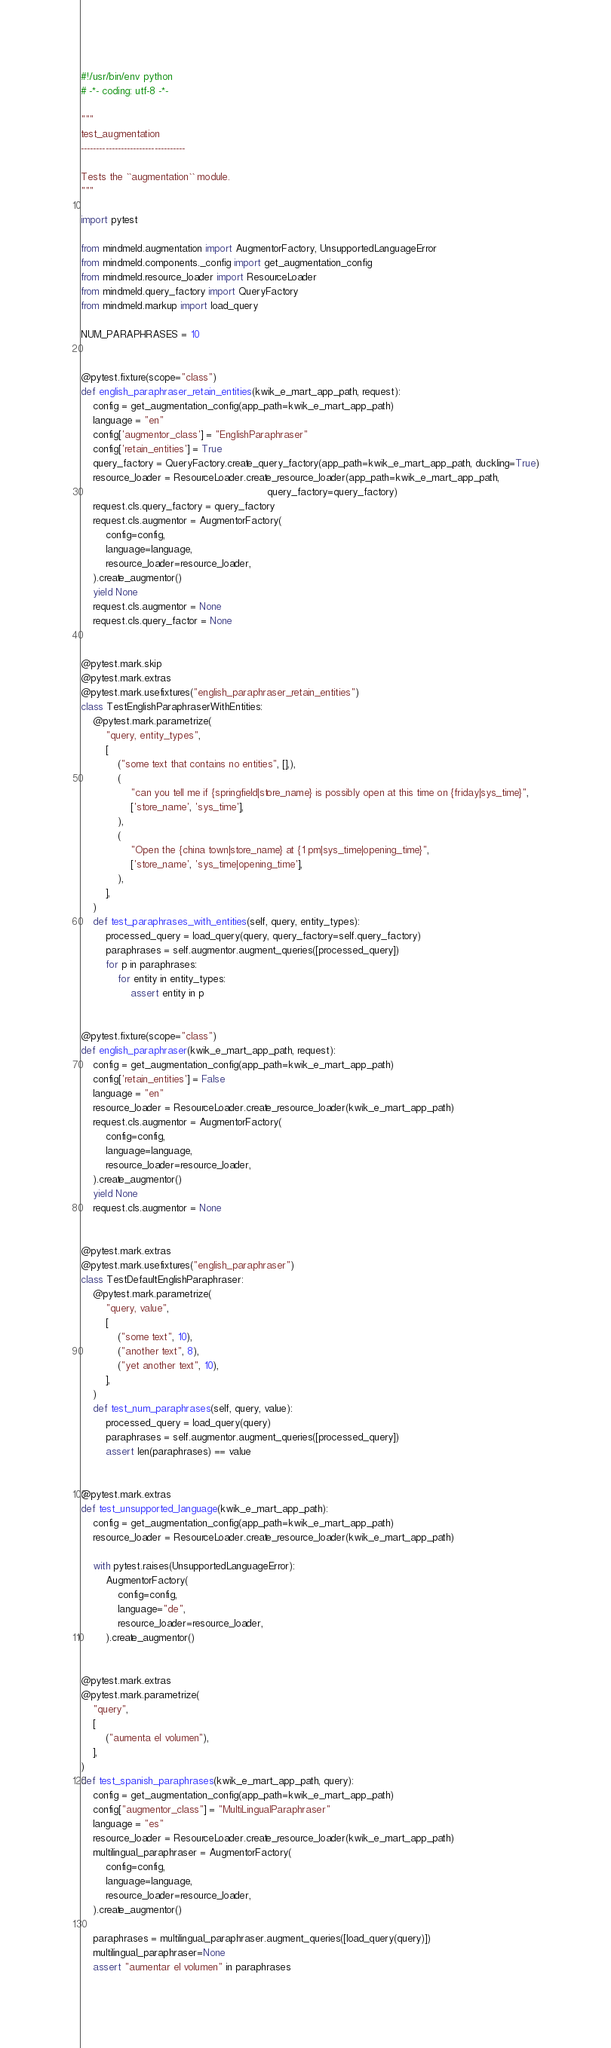<code> <loc_0><loc_0><loc_500><loc_500><_Python_>#!/usr/bin/env python
# -*- coding: utf-8 -*-

"""
test_augmentation
----------------------------------

Tests the ``augmentation`` module.
"""

import pytest

from mindmeld.augmentation import AugmentorFactory, UnsupportedLanguageError
from mindmeld.components._config import get_augmentation_config
from mindmeld.resource_loader import ResourceLoader
from mindmeld.query_factory import QueryFactory
from mindmeld.markup import load_query

NUM_PARAPHRASES = 10


@pytest.fixture(scope="class")
def english_paraphraser_retain_entities(kwik_e_mart_app_path, request):
    config = get_augmentation_config(app_path=kwik_e_mart_app_path)
    language = "en"
    config['augmentor_class'] = "EnglishParaphraser"
    config['retain_entities'] = True
    query_factory = QueryFactory.create_query_factory(app_path=kwik_e_mart_app_path, duckling=True)
    resource_loader = ResourceLoader.create_resource_loader(app_path=kwik_e_mart_app_path,
                                                            query_factory=query_factory)
    request.cls.query_factory = query_factory
    request.cls.augmentor = AugmentorFactory(
        config=config,
        language=language,
        resource_loader=resource_loader,
    ).create_augmentor()
    yield None
    request.cls.augmentor = None
    request.cls.query_factor = None


@pytest.mark.skip
@pytest.mark.extras
@pytest.mark.usefixtures("english_paraphraser_retain_entities")
class TestEnglishParaphraserWithEntities:
    @pytest.mark.parametrize(
        "query, entity_types",
        [
            ("some text that contains no entities", [],),
            (
                "can you tell me if {springfield|store_name} is possibly open at this time on {friday|sys_time}",
                ['store_name', 'sys_time'],
            ),
            (
                "Open the {china town|store_name} at {1 pm|sys_time|opening_time}",
                ['store_name', 'sys_time|opening_time'],
            ),
        ],
    )
    def test_paraphrases_with_entities(self, query, entity_types):
        processed_query = load_query(query, query_factory=self.query_factory)
        paraphrases = self.augmentor.augment_queries([processed_query])
        for p in paraphrases:
            for entity in entity_types:
                assert entity in p


@pytest.fixture(scope="class")
def english_paraphraser(kwik_e_mart_app_path, request):
    config = get_augmentation_config(app_path=kwik_e_mart_app_path)
    config['retain_entities'] = False
    language = "en"
    resource_loader = ResourceLoader.create_resource_loader(kwik_e_mart_app_path)
    request.cls.augmentor = AugmentorFactory(
        config=config,
        language=language,
        resource_loader=resource_loader,
    ).create_augmentor()
    yield None
    request.cls.augmentor = None


@pytest.mark.extras
@pytest.mark.usefixtures("english_paraphraser")
class TestDefaultEnglishParaphraser:
    @pytest.mark.parametrize(
        "query, value",
        [
            ("some text", 10),
            ("another text", 8),
            ("yet another text", 10),
        ],
    )
    def test_num_paraphrases(self, query, value):
        processed_query = load_query(query)
        paraphrases = self.augmentor.augment_queries([processed_query])
        assert len(paraphrases) == value


@pytest.mark.extras
def test_unsupported_language(kwik_e_mart_app_path):
    config = get_augmentation_config(app_path=kwik_e_mart_app_path)
    resource_loader = ResourceLoader.create_resource_loader(kwik_e_mart_app_path)

    with pytest.raises(UnsupportedLanguageError):
        AugmentorFactory(
            config=config,
            language="de",
            resource_loader=resource_loader,
        ).create_augmentor()


@pytest.mark.extras
@pytest.mark.parametrize(
    "query",
    [
        ("aumenta el volumen"),
    ],
)
def test_spanish_paraphrases(kwik_e_mart_app_path, query):
    config = get_augmentation_config(app_path=kwik_e_mart_app_path)
    config["augmentor_class"] = "MultiLingualParaphraser"
    language = "es"
    resource_loader = ResourceLoader.create_resource_loader(kwik_e_mart_app_path)
    multilingual_paraphraser = AugmentorFactory(
        config=config,
        language=language,
        resource_loader=resource_loader,
    ).create_augmentor()

    paraphrases = multilingual_paraphraser.augment_queries([load_query(query)])
    multilingual_paraphraser=None
    assert "aumentar el volumen" in paraphrases
</code> 